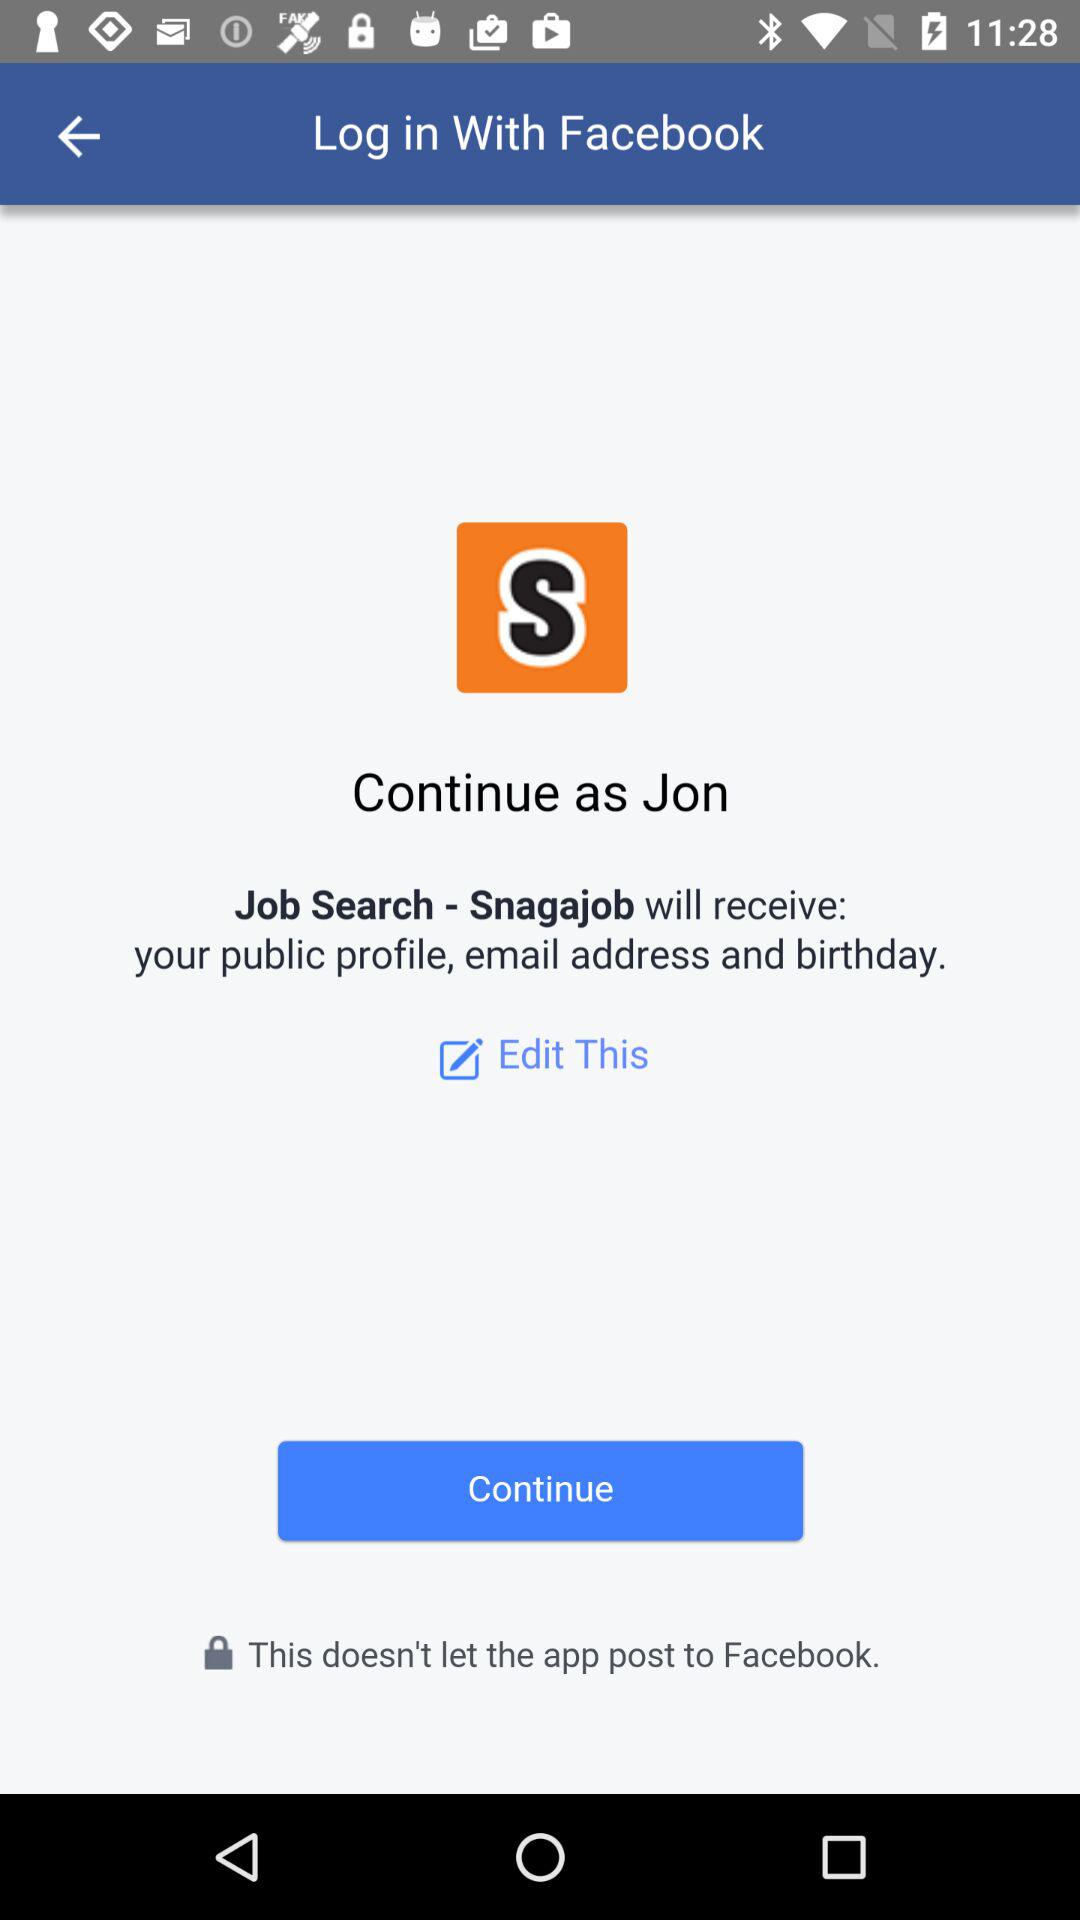What application is asking for permission? The application that is asking for permission is "Job Search - Snagajob". 